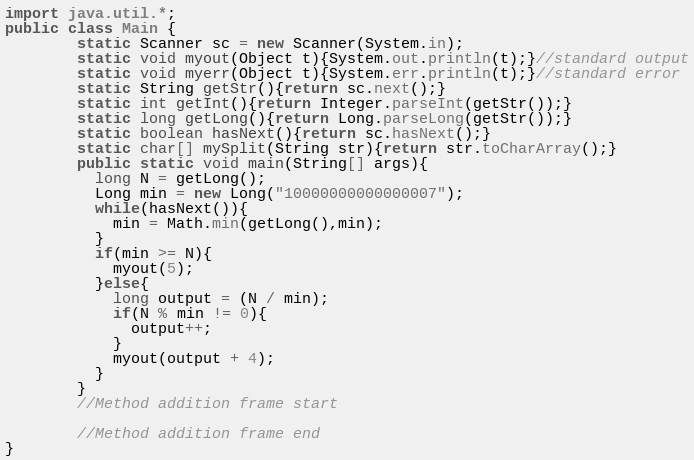Convert code to text. <code><loc_0><loc_0><loc_500><loc_500><_Java_>import java.util.*;
public class Main {
        static Scanner sc = new Scanner(System.in);
        static void myout(Object t){System.out.println(t);}//standard output
        static void myerr(Object t){System.err.println(t);}//standard error
        static String getStr(){return sc.next();}
        static int getInt(){return Integer.parseInt(getStr());}
        static long getLong(){return Long.parseLong(getStr());}
        static boolean hasNext(){return sc.hasNext();}
        static char[] mySplit(String str){return str.toCharArray();}
        public static void main(String[] args){
          long N = getLong();
          Long min = new Long("10000000000000007");
          while(hasNext()){
            min = Math.min(getLong(),min);
          }
          if(min >= N){
            myout(5);
          }else{
            long output = (N / min);
            if(N % min != 0){
              output++;
            }
            myout(output + 4);
          }
        }
        //Method addition frame start

        //Method addition frame end
}
</code> 